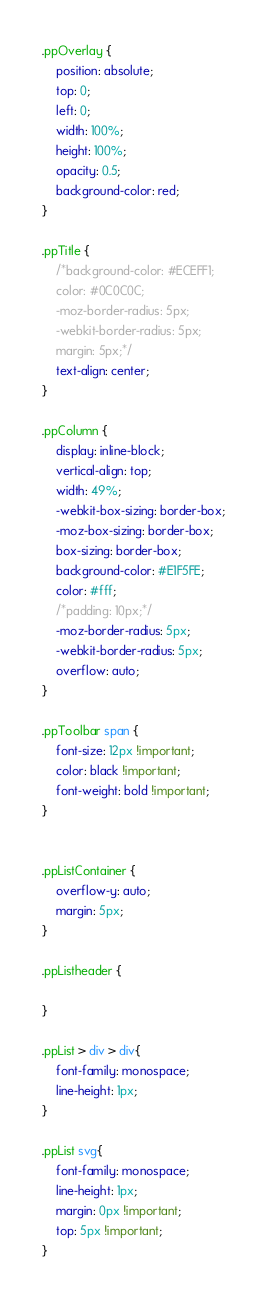<code> <loc_0><loc_0><loc_500><loc_500><_CSS_>.ppOverlay {
    position: absolute;
    top: 0;
    left: 0;
    width: 100%; 
    height: 100%;
    opacity: 0.5;
    background-color: red;
}

.ppTitle {
    /*background-color: #ECEFF1;
	color: #0C0C0C;
	-moz-border-radius: 5px;
	-webkit-border-radius: 5px;
    margin: 5px;*/
    text-align: center;
}

.ppColumn {
    display: inline-block;
    vertical-align: top;
    width: 49%;
    -webkit-box-sizing: border-box;
    -moz-box-sizing: border-box;
    box-sizing: border-box;
    background-color: #E1F5FE;
	color: #fff;
	/*padding: 10px;*/
	-moz-border-radius: 5px;
	-webkit-border-radius: 5px;
    overflow: auto;
}

.ppToolbar span {
    font-size: 12px !important;
    color: black !important;
    font-weight: bold !important;
}


.ppListContainer {
    overflow-y: auto;
    margin: 5px;
}

.ppListheader {

}

.ppList > div > div{
    font-family: monospace;
    line-height: 1px; 
}

.ppList svg{
    font-family: monospace;
    line-height: 1px;
    margin: 0px !important;
    top: 5px !important;
}

</code> 